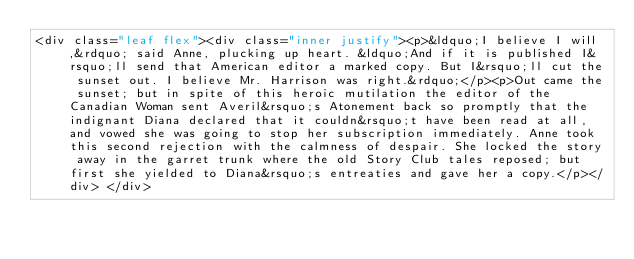<code> <loc_0><loc_0><loc_500><loc_500><_HTML_><div class="leaf flex"><div class="inner justify"><p>&ldquo;I believe I will,&rdquo; said Anne, plucking up heart. &ldquo;And if it is published I&rsquo;ll send that American editor a marked copy. But I&rsquo;ll cut the sunset out. I believe Mr. Harrison was right.&rdquo;</p><p>Out came the sunset; but in spite of this heroic mutilation the editor of the Canadian Woman sent Averil&rsquo;s Atonement back so promptly that the indignant Diana declared that it couldn&rsquo;t have been read at all, and vowed she was going to stop her subscription immediately. Anne took this second rejection with the calmness of despair. She locked the story away in the garret trunk where the old Story Club tales reposed; but first she yielded to Diana&rsquo;s entreaties and gave her a copy.</p></div> </div></code> 